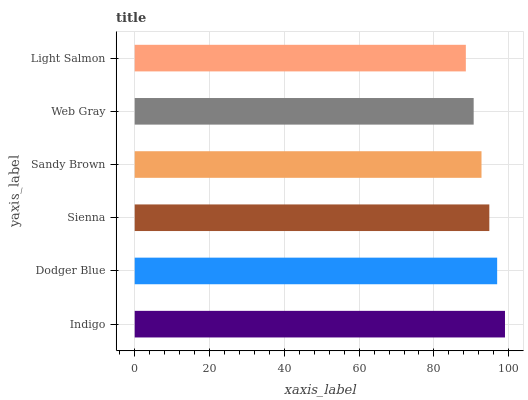Is Light Salmon the minimum?
Answer yes or no. Yes. Is Indigo the maximum?
Answer yes or no. Yes. Is Dodger Blue the minimum?
Answer yes or no. No. Is Dodger Blue the maximum?
Answer yes or no. No. Is Indigo greater than Dodger Blue?
Answer yes or no. Yes. Is Dodger Blue less than Indigo?
Answer yes or no. Yes. Is Dodger Blue greater than Indigo?
Answer yes or no. No. Is Indigo less than Dodger Blue?
Answer yes or no. No. Is Sienna the high median?
Answer yes or no. Yes. Is Sandy Brown the low median?
Answer yes or no. Yes. Is Sandy Brown the high median?
Answer yes or no. No. Is Sienna the low median?
Answer yes or no. No. 